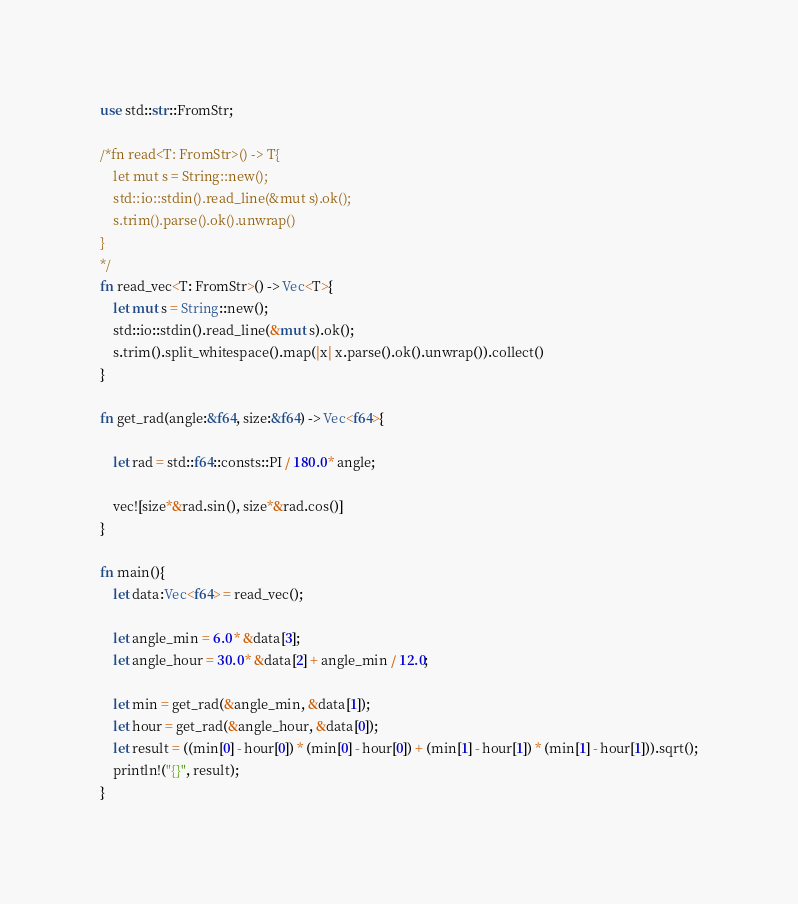<code> <loc_0><loc_0><loc_500><loc_500><_Rust_>use std::str::FromStr;
 
/*fn read<T: FromStr>() -> T{
    let mut s = String::new();
    std::io::stdin().read_line(&mut s).ok();
    s.trim().parse().ok().unwrap()
}
*/
fn read_vec<T: FromStr>() -> Vec<T>{
    let mut s = String::new();
    std::io::stdin().read_line(&mut s).ok();
    s.trim().split_whitespace().map(|x| x.parse().ok().unwrap()).collect()
}
 
fn get_rad(angle:&f64, size:&f64) -> Vec<f64>{
    
    let rad = std::f64::consts::PI / 180.0 * angle; 
    
    vec![size*&rad.sin(), size*&rad.cos()]
}
 
fn main(){
    let data:Vec<f64> = read_vec();
    
    let angle_min = 6.0 * &data[3];
    let angle_hour = 30.0 * &data[2] + angle_min / 12.0;
    
    let min = get_rad(&angle_min, &data[1]);
    let hour = get_rad(&angle_hour, &data[0]);
    let result = ((min[0] - hour[0]) * (min[0] - hour[0]) + (min[1] - hour[1]) * (min[1] - hour[1])).sqrt();
    println!("{}", result);
}</code> 